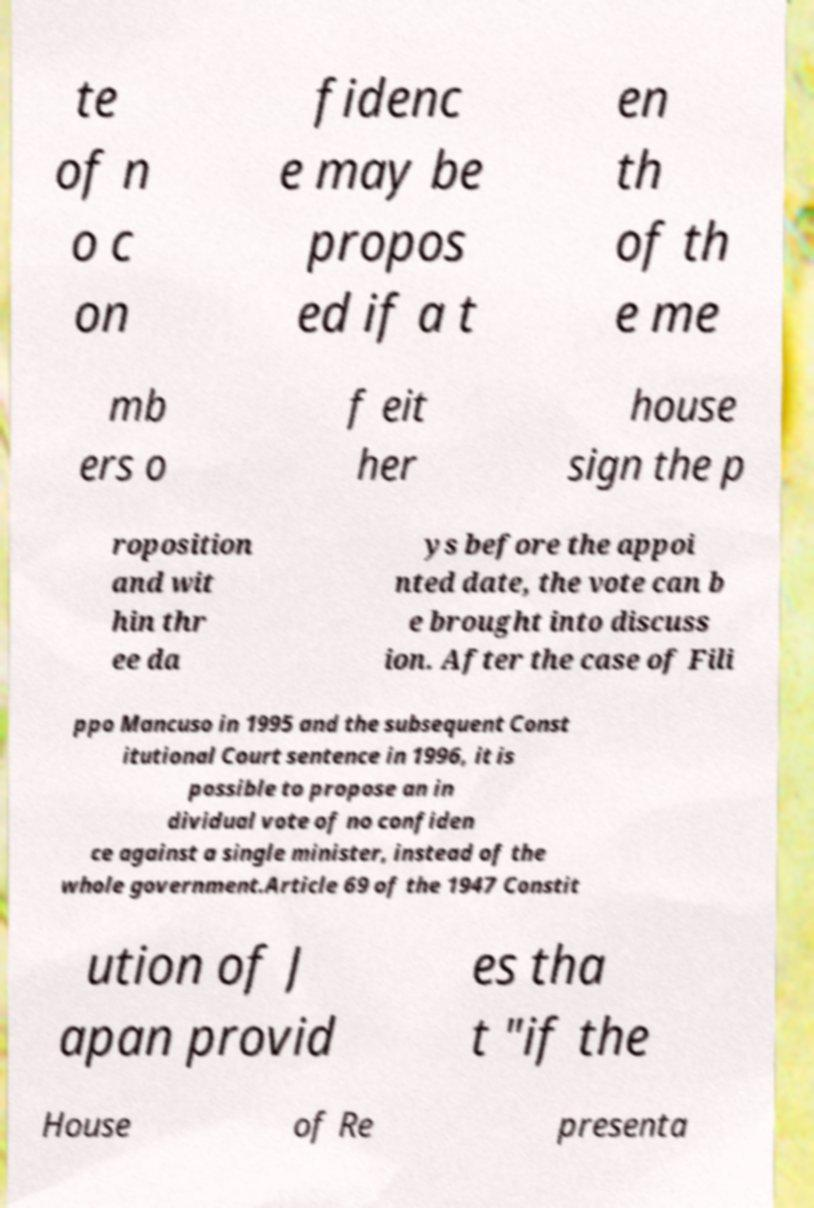What messages or text are displayed in this image? I need them in a readable, typed format. te of n o c on fidenc e may be propos ed if a t en th of th e me mb ers o f eit her house sign the p roposition and wit hin thr ee da ys before the appoi nted date, the vote can b e brought into discuss ion. After the case of Fili ppo Mancuso in 1995 and the subsequent Const itutional Court sentence in 1996, it is possible to propose an in dividual vote of no confiden ce against a single minister, instead of the whole government.Article 69 of the 1947 Constit ution of J apan provid es tha t "if the House of Re presenta 